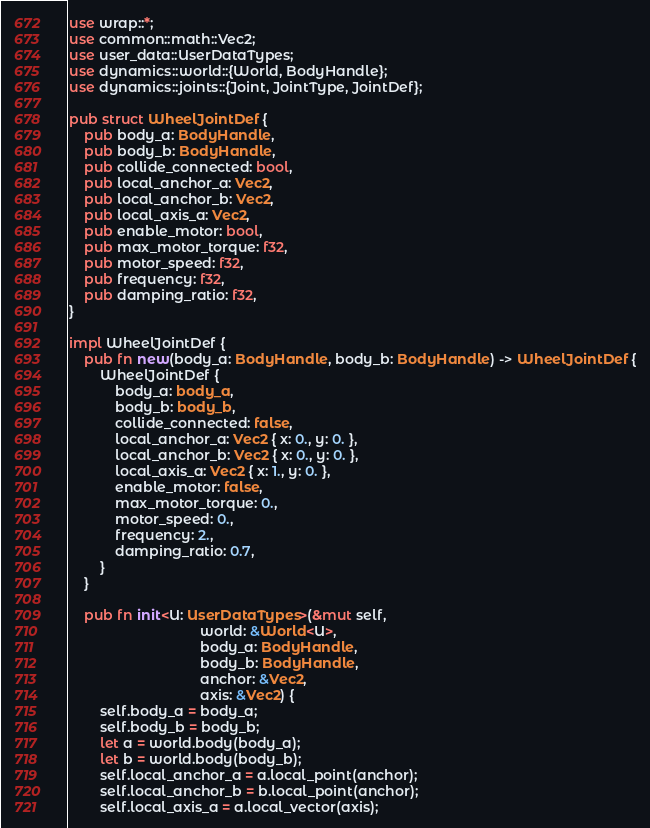Convert code to text. <code><loc_0><loc_0><loc_500><loc_500><_Rust_>use wrap::*;
use common::math::Vec2;
use user_data::UserDataTypes;
use dynamics::world::{World, BodyHandle};
use dynamics::joints::{Joint, JointType, JointDef};

pub struct WheelJointDef {
    pub body_a: BodyHandle,
    pub body_b: BodyHandle,
    pub collide_connected: bool,
    pub local_anchor_a: Vec2,
    pub local_anchor_b: Vec2,
    pub local_axis_a: Vec2,
    pub enable_motor: bool,
    pub max_motor_torque: f32,
    pub motor_speed: f32,
    pub frequency: f32,
    pub damping_ratio: f32,
}

impl WheelJointDef {
    pub fn new(body_a: BodyHandle, body_b: BodyHandle) -> WheelJointDef {
        WheelJointDef {
            body_a: body_a,
            body_b: body_b,
            collide_connected: false,
            local_anchor_a: Vec2 { x: 0., y: 0. },
            local_anchor_b: Vec2 { x: 0., y: 0. },
            local_axis_a: Vec2 { x: 1., y: 0. },
            enable_motor: false,
            max_motor_torque: 0.,
            motor_speed: 0.,
            frequency: 2.,
            damping_ratio: 0.7,
        }
    }

    pub fn init<U: UserDataTypes>(&mut self,
                                  world: &World<U>,
                                  body_a: BodyHandle,
                                  body_b: BodyHandle,
                                  anchor: &Vec2,
                                  axis: &Vec2) {
        self.body_a = body_a;
        self.body_b = body_b;
        let a = world.body(body_a);
        let b = world.body(body_b);
        self.local_anchor_a = a.local_point(anchor);
        self.local_anchor_b = b.local_point(anchor);
        self.local_axis_a = a.local_vector(axis);</code> 